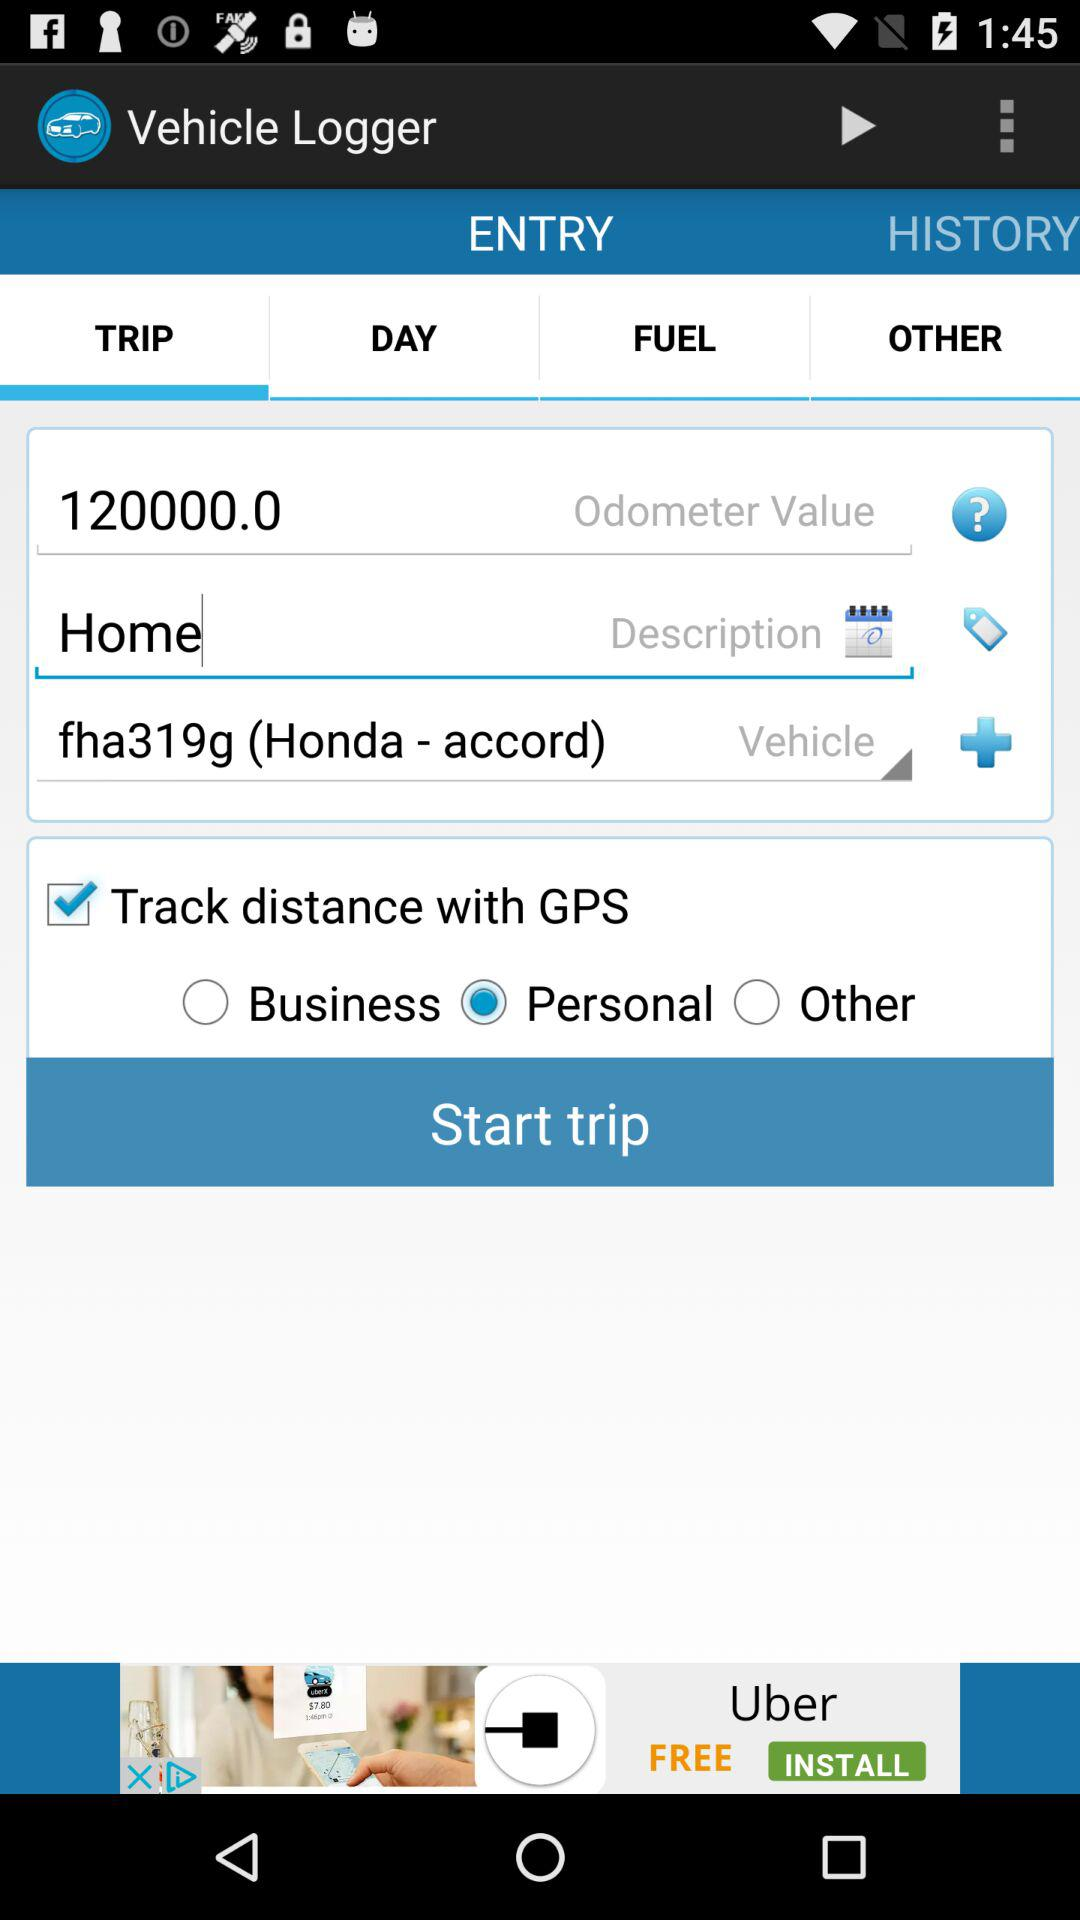What's the odometer value? The odometer value is 120000.0. 